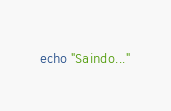<code> <loc_0><loc_0><loc_500><loc_500><_Bash_>
echo "Saindo..."</code> 